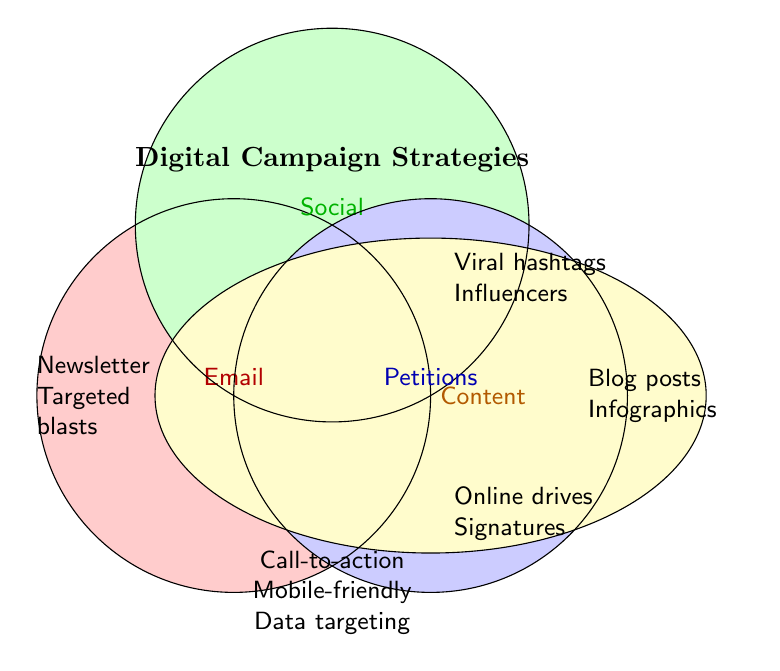What is the title of the figure? The title is usually located at the top of the figure and identifies the main topic of the figure. In this figure, the title "Digital Campaign Strategies" is prominently placed at the top.
Answer: Digital Campaign Strategies Which category is represented with the green color? To determine the category, we need to look at the labels next to the colored sections in the figure. The green color is labeled as "Social," representing Social Media strategies.
Answer: Social What digital campaigns are exclusively within the 'Email' category? Check the section labeled as "Email," which is represented by the red color. The campaigns listed there are "Newsletter" and "Targeted blasts."
Answer: Newsletter, Targeted blasts What strategies are common to all categories? The common strategies to all categories are displayed in the intersection of all the circles. In this case, "Call-to-action buttons," "Mobile-friendly design," and "Data-driven targeting" are listed in the center intersecting area.
Answer: Call-to-action buttons, Mobile-friendly design, Data-driven targeting Which content marketing strategies are mentioned in the figure? By observing the area labeled as "Content" (yellow), we can identify the listed strategies. They are "Blog posts" and "Infographics."
Answer: Blog posts, Infographics Which strategies are unique to petitions? Look at the blue section labeled "Petitions." The unique strategies listed there include "Online drives" and "Signatures."
Answer: Online drives, Signatures Compare the strategies listed in the 'Email' and 'Social' categories. Which strategy categories have more individual strategies listed? "Email" and "Social" categories each have two individual strategies listed. So, both have an equal number of strategies.
Answer: Equal How many strategies are associated with the 'Social Media' category? Count the individual strategies listed under the green-colored section labeled "Social." There are two strategies: "Viral hashtags" and "Influencers."
Answer: 2 Which category appears to overlap with all other categories the least? Look at the diagram intersections. The 'Email' section has the fewest overlaps compared to others; the significant intersection mainly appears between Social Media, Petitions, and Content Marketing.
Answer: Email 